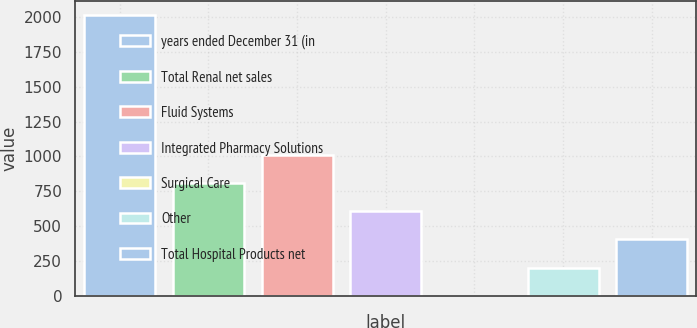Convert chart. <chart><loc_0><loc_0><loc_500><loc_500><bar_chart><fcel>years ended December 31 (in<fcel>Total Renal net sales<fcel>Fluid Systems<fcel>Integrated Pharmacy Solutions<fcel>Surgical Care<fcel>Other<fcel>Total Hospital Products net<nl><fcel>2016<fcel>807<fcel>1008.5<fcel>605.5<fcel>1<fcel>202.5<fcel>404<nl></chart> 